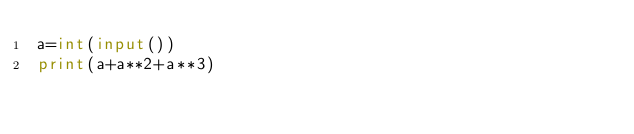<code> <loc_0><loc_0><loc_500><loc_500><_Python_>a=int(input())
print(a+a**2+a**3)</code> 